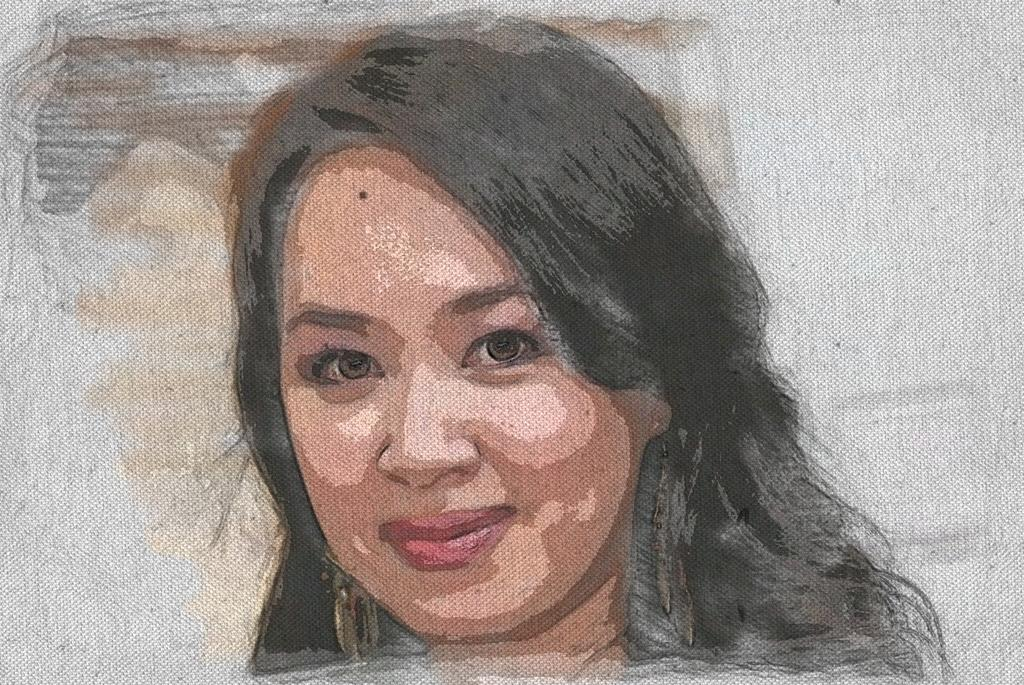What is the main subject of the image? There is a picture of a woman in the image. Can you describe the woman in the picture? Unfortunately, the provided facts do not include any details about the woman's appearance or clothing. Is there any context or setting provided for the image? No, the only fact given is that there is a picture of a woman in the image. How many rings are the woman wearing in the image? There is no information provided about the woman's apparel, including any rings she might be wearing. 